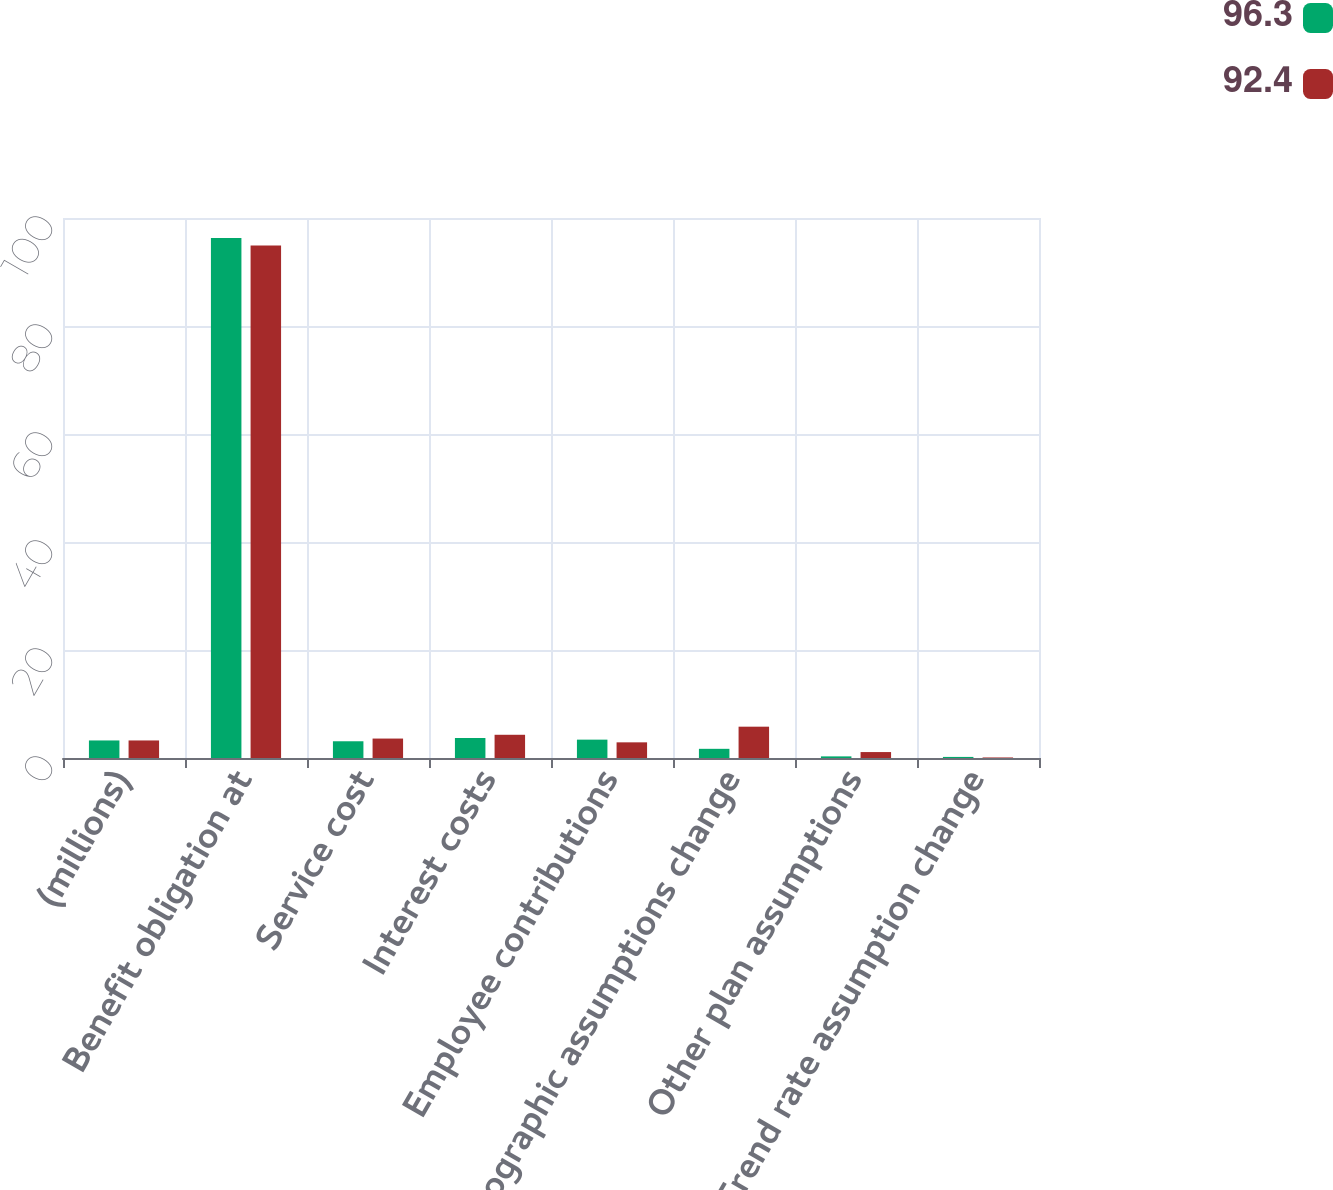<chart> <loc_0><loc_0><loc_500><loc_500><stacked_bar_chart><ecel><fcel>(millions)<fcel>Benefit obligation at<fcel>Service cost<fcel>Interest costs<fcel>Employee contributions<fcel>Demographic assumptions change<fcel>Other plan assumptions<fcel>Trend rate assumption change<nl><fcel>96.3<fcel>3.25<fcel>96.3<fcel>3.1<fcel>3.7<fcel>3.4<fcel>1.7<fcel>0.3<fcel>0.2<nl><fcel>92.4<fcel>3.25<fcel>94.9<fcel>3.6<fcel>4.3<fcel>2.9<fcel>5.8<fcel>1.1<fcel>0.1<nl></chart> 